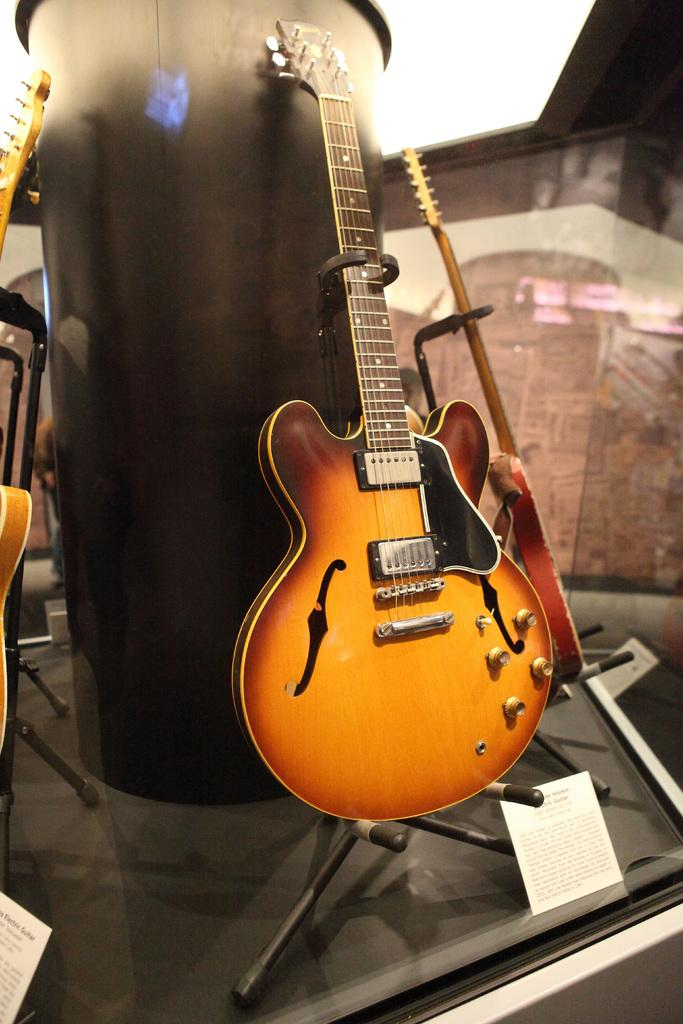How many guitars are visible in the image? There are three guitars in the image. What is the guitars' position in relation to each other? The guitars are fixed to a metal pole. What type of comfort can be found in the image? There is no reference to comfort in the image, as it features guitars fixed to a metal pole. 